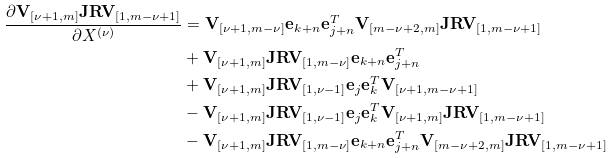<formula> <loc_0><loc_0><loc_500><loc_500>\frac { \partial \mathbf V _ { [ \nu + 1 , m ] } \mathbf J \mathbf R \mathbf V _ { [ 1 , m - \nu + 1 ] } } { \partial X ^ { ( \nu ) } } & = \mathbf V _ { [ \nu + 1 , m - \nu ] } \mathbf e _ { k + n } \mathbf e _ { j + n } ^ { T } \mathbf V _ { [ m - \nu + 2 , m ] } \mathbf J \mathbf R \mathbf V _ { [ 1 , m - \nu + 1 ] } \\ & + \mathbf V _ { [ \nu + 1 , m ] } \mathbf J \mathbf R \mathbf V _ { [ 1 , m - \nu ] } \mathbf e _ { k + n } \mathbf e _ { j + n } ^ { T } \\ & + \mathbf V _ { [ \nu + 1 , m ] } \mathbf J \mathbf R \mathbf V _ { [ 1 , \nu - 1 ] } \mathbf e _ { j } \mathbf e _ { k } ^ { T } \mathbf V _ { [ \nu + 1 , m - \nu + 1 ] } \\ & - \mathbf V _ { [ \nu + 1 , m ] } \mathbf J \mathbf R \mathbf V _ { [ 1 , \nu - 1 ] } \mathbf e _ { j } \mathbf e _ { k } ^ { T } \mathbf V _ { [ \nu + 1 , m ] } \mathbf J \mathbf R \mathbf V _ { [ 1 , m - \nu + 1 ] } \\ & - \mathbf V _ { [ \nu + 1 , m ] } \mathbf J \mathbf R \mathbf V _ { [ 1 , m - \nu ] } \mathbf e _ { k + n } \mathbf e _ { j + n } ^ { T } \mathbf V _ { [ m - \nu + 2 , m ] } \mathbf J \mathbf R \mathbf V _ { [ 1 , m - \nu + 1 ] }</formula> 